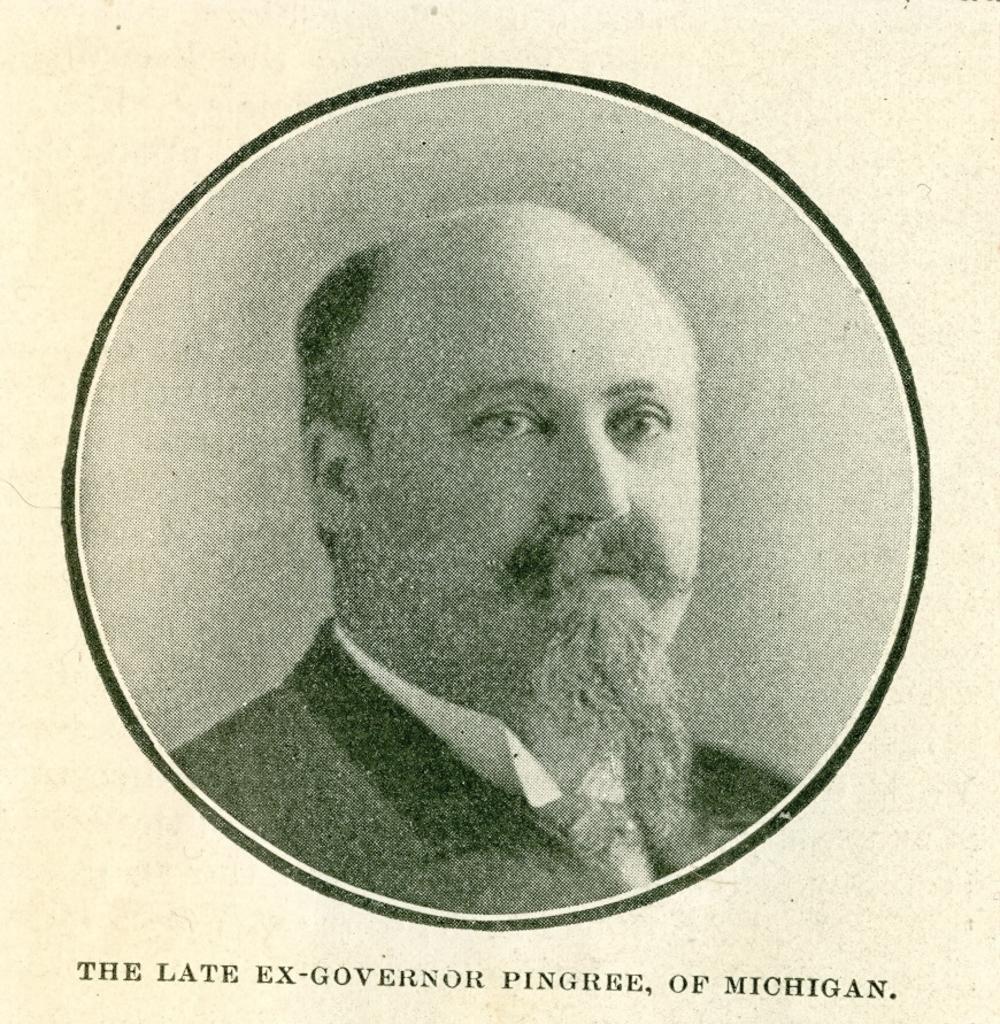Please provide a concise description of this image. In this picture there is a image of a person which is in circle shape and there is something written below it. 